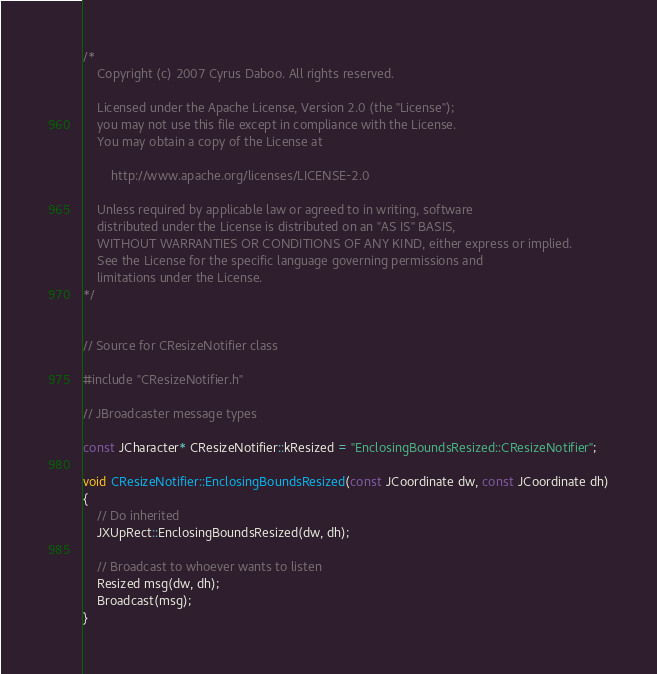<code> <loc_0><loc_0><loc_500><loc_500><_C++_>/*
    Copyright (c) 2007 Cyrus Daboo. All rights reserved.
    
    Licensed under the Apache License, Version 2.0 (the "License");
    you may not use this file except in compliance with the License.
    You may obtain a copy of the License at
    
        http://www.apache.org/licenses/LICENSE-2.0
    
    Unless required by applicable law or agreed to in writing, software
    distributed under the License is distributed on an "AS IS" BASIS,
    WITHOUT WARRANTIES OR CONDITIONS OF ANY KIND, either express or implied.
    See the License for the specific language governing permissions and
    limitations under the License.
*/


// Source for CResizeNotifier class

#include "CResizeNotifier.h"

// JBroadcaster message types

const JCharacter* CResizeNotifier::kResized = "EnclosingBoundsResized::CResizeNotifier";

void CResizeNotifier::EnclosingBoundsResized(const JCoordinate dw, const JCoordinate dh)
{
	// Do inherited
	JXUpRect::EnclosingBoundsResized(dw, dh);

	// Broadcast to whoever wants to listen
	Resized msg(dw, dh);
	Broadcast(msg);
}
</code> 